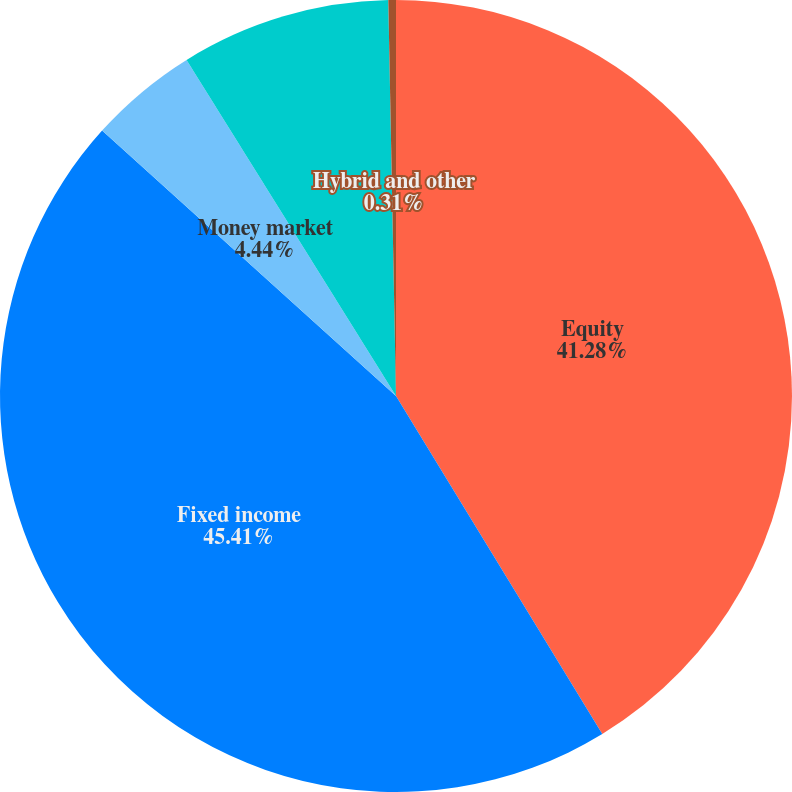<chart> <loc_0><loc_0><loc_500><loc_500><pie_chart><fcel>Equity<fcel>Fixed income<fcel>Money market<fcel>Alternative<fcel>Hybrid and other<nl><fcel>41.28%<fcel>45.41%<fcel>4.44%<fcel>8.56%<fcel>0.31%<nl></chart> 